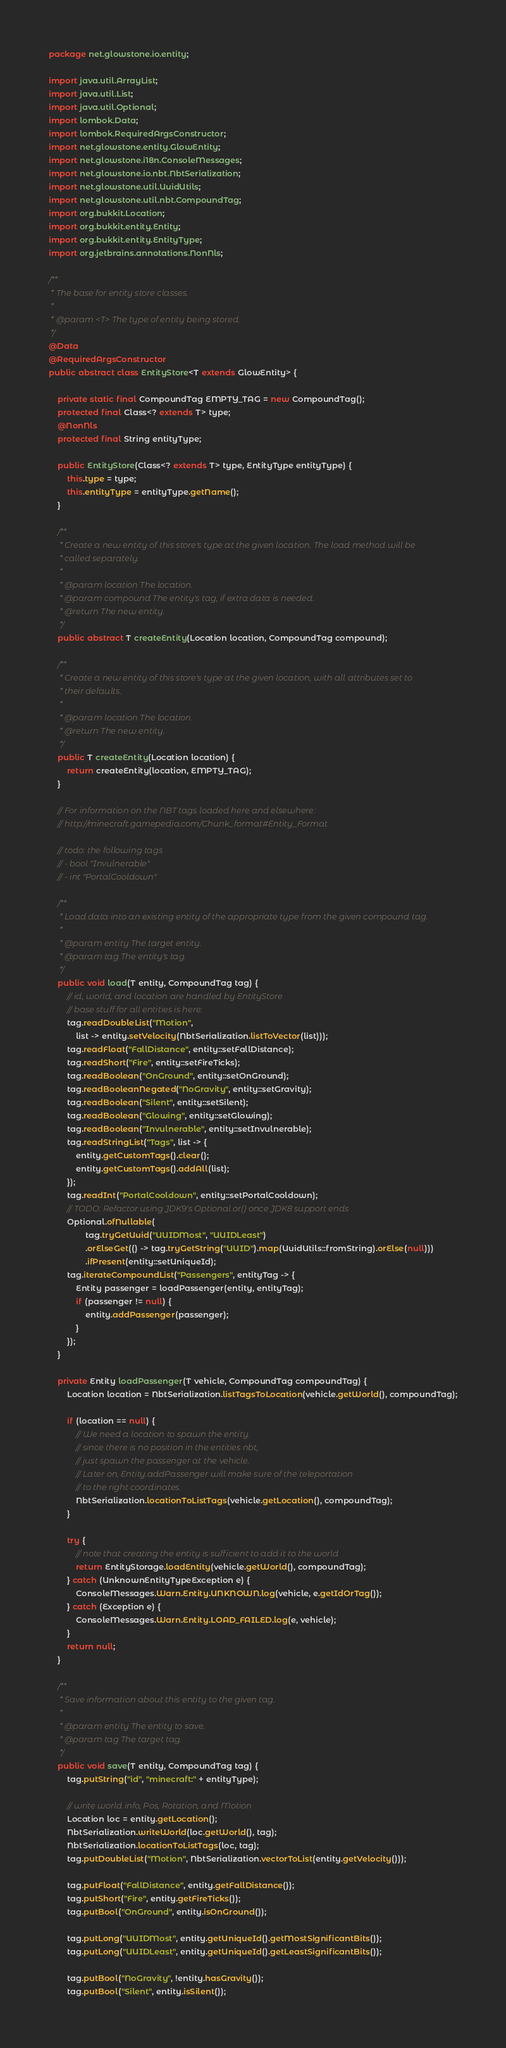Convert code to text. <code><loc_0><loc_0><loc_500><loc_500><_Java_>package net.glowstone.io.entity;

import java.util.ArrayList;
import java.util.List;
import java.util.Optional;
import lombok.Data;
import lombok.RequiredArgsConstructor;
import net.glowstone.entity.GlowEntity;
import net.glowstone.i18n.ConsoleMessages;
import net.glowstone.io.nbt.NbtSerialization;
import net.glowstone.util.UuidUtils;
import net.glowstone.util.nbt.CompoundTag;
import org.bukkit.Location;
import org.bukkit.entity.Entity;
import org.bukkit.entity.EntityType;
import org.jetbrains.annotations.NonNls;

/**
 * The base for entity store classes.
 *
 * @param <T> The type of entity being stored.
 */
@Data
@RequiredArgsConstructor
public abstract class EntityStore<T extends GlowEntity> {

    private static final CompoundTag EMPTY_TAG = new CompoundTag();
    protected final Class<? extends T> type;
    @NonNls
    protected final String entityType;

    public EntityStore(Class<? extends T> type, EntityType entityType) {
        this.type = type;
        this.entityType = entityType.getName();
    }

    /**
     * Create a new entity of this store's type at the given location. The load method will be
     * called separately.
     *
     * @param location The location.
     * @param compound The entity's tag, if extra data is needed.
     * @return The new entity.
     */
    public abstract T createEntity(Location location, CompoundTag compound);

    /**
     * Create a new entity of this store's type at the given location, with all attributes set to
     * their defaults.
     *
     * @param location The location.
     * @return The new entity.
     */
    public T createEntity(Location location) {
        return createEntity(location, EMPTY_TAG);
    }

    // For information on the NBT tags loaded here and elsewhere:
    // http://minecraft.gamepedia.com/Chunk_format#Entity_Format

    // todo: the following tags
    // - bool "Invulnerable"
    // - int "PortalCooldown"

    /**
     * Load data into an existing entity of the appropriate type from the given compound tag.
     *
     * @param entity The target entity.
     * @param tag The entity's tag.
     */
    public void load(T entity, CompoundTag tag) {
        // id, world, and location are handled by EntityStore
        // base stuff for all entities is here:
        tag.readDoubleList("Motion",
            list -> entity.setVelocity(NbtSerialization.listToVector(list)));
        tag.readFloat("FallDistance", entity::setFallDistance);
        tag.readShort("Fire", entity::setFireTicks);
        tag.readBoolean("OnGround", entity::setOnGround);
        tag.readBooleanNegated("NoGravity", entity::setGravity);
        tag.readBoolean("Silent", entity::setSilent);
        tag.readBoolean("Glowing", entity::setGlowing);
        tag.readBoolean("Invulnerable", entity::setInvulnerable);
        tag.readStringList("Tags", list -> {
            entity.getCustomTags().clear();
            entity.getCustomTags().addAll(list);
        });
        tag.readInt("PortalCooldown", entity::setPortalCooldown);
        // TODO: Refactor using JDK9's Optional.or() once JDK8 support ends
        Optional.ofNullable(
                tag.tryGetUuid("UUIDMost", "UUIDLeast")
                .orElseGet(() -> tag.tryGetString("UUID").map(UuidUtils::fromString).orElse(null)))
                .ifPresent(entity::setUniqueId);
        tag.iterateCompoundList("Passengers", entityTag -> {
            Entity passenger = loadPassenger(entity, entityTag);
            if (passenger != null) {
                entity.addPassenger(passenger);
            }
        });
    }

    private Entity loadPassenger(T vehicle, CompoundTag compoundTag) {
        Location location = NbtSerialization.listTagsToLocation(vehicle.getWorld(), compoundTag);

        if (location == null) {
            // We need a location to spawn the entity.
            // since there is no position in the entities nbt,
            // just spawn the passenger at the vehicle.
            // Later on, Entity.addPassenger will make sure of the teleportation
            // to the right coordinates.
            NbtSerialization.locationToListTags(vehicle.getLocation(), compoundTag);
        }

        try {
            // note that creating the entity is sufficient to add it to the world
            return EntityStorage.loadEntity(vehicle.getWorld(), compoundTag);
        } catch (UnknownEntityTypeException e) {
            ConsoleMessages.Warn.Entity.UNKNOWN.log(vehicle, e.getIdOrTag());
        } catch (Exception e) {
            ConsoleMessages.Warn.Entity.LOAD_FAILED.log(e, vehicle);
        }
        return null;
    }

    /**
     * Save information about this entity to the given tag.
     *
     * @param entity The entity to save.
     * @param tag The target tag.
     */
    public void save(T entity, CompoundTag tag) {
        tag.putString("id", "minecraft:" + entityType);

        // write world info, Pos, Rotation, and Motion
        Location loc = entity.getLocation();
        NbtSerialization.writeWorld(loc.getWorld(), tag);
        NbtSerialization.locationToListTags(loc, tag);
        tag.putDoubleList("Motion", NbtSerialization.vectorToList(entity.getVelocity()));

        tag.putFloat("FallDistance", entity.getFallDistance());
        tag.putShort("Fire", entity.getFireTicks());
        tag.putBool("OnGround", entity.isOnGround());

        tag.putLong("UUIDMost", entity.getUniqueId().getMostSignificantBits());
        tag.putLong("UUIDLeast", entity.getUniqueId().getLeastSignificantBits());

        tag.putBool("NoGravity", !entity.hasGravity());
        tag.putBool("Silent", entity.isSilent());</code> 